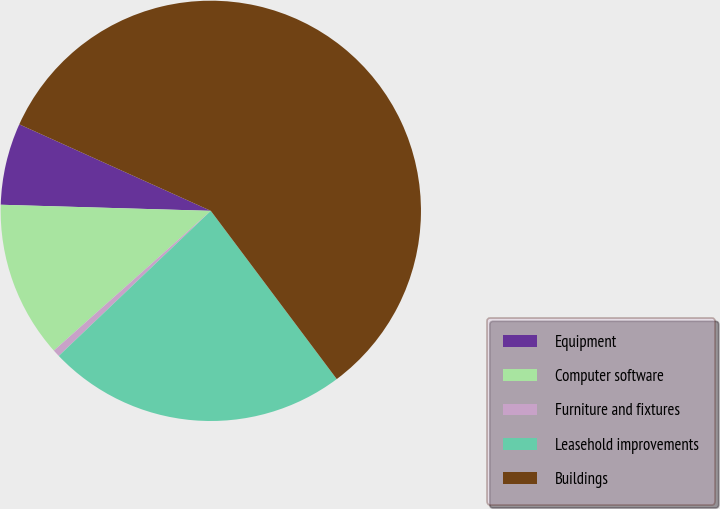<chart> <loc_0><loc_0><loc_500><loc_500><pie_chart><fcel>Equipment<fcel>Computer software<fcel>Furniture and fixtures<fcel>Leasehold improvements<fcel>Buildings<nl><fcel>6.29%<fcel>12.04%<fcel>0.55%<fcel>23.1%<fcel>58.02%<nl></chart> 